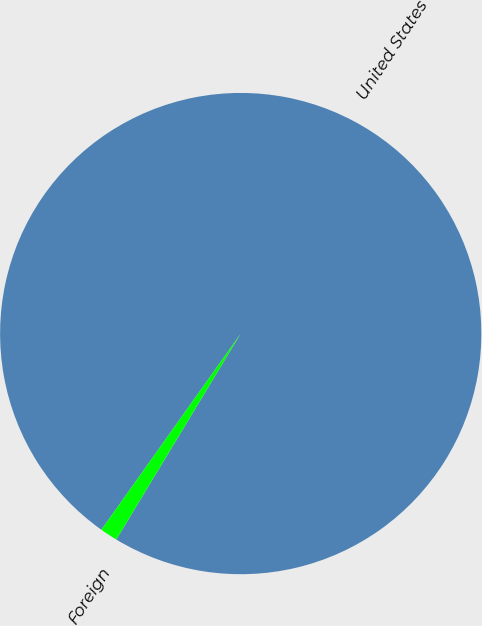Convert chart to OTSL. <chart><loc_0><loc_0><loc_500><loc_500><pie_chart><fcel>United States<fcel>Foreign<nl><fcel>98.82%<fcel>1.18%<nl></chart> 